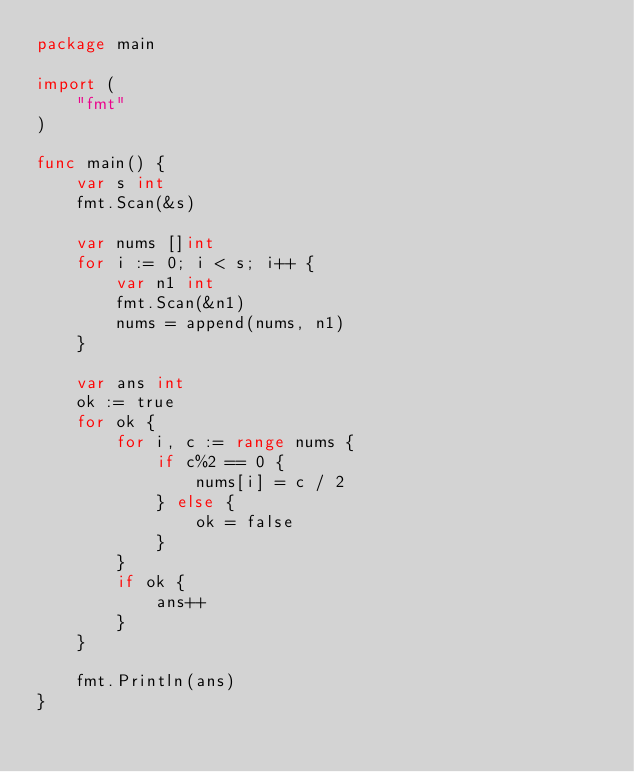<code> <loc_0><loc_0><loc_500><loc_500><_Go_>package main

import (
	"fmt"
)

func main() {
	var s int
	fmt.Scan(&s)

	var nums []int
	for i := 0; i < s; i++ {
		var n1 int
		fmt.Scan(&n1)
		nums = append(nums, n1)
	}

	var ans int
	ok := true
	for ok {
		for i, c := range nums {
			if c%2 == 0 {
				nums[i] = c / 2
			} else {
				ok = false
			}
		}
		if ok {
			ans++
		}
	}

	fmt.Println(ans)
}
</code> 